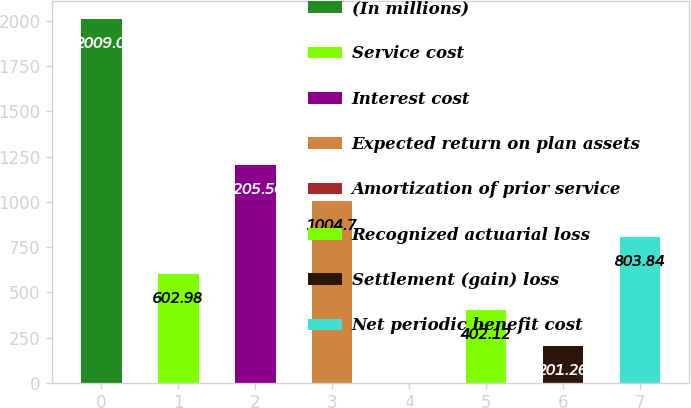Convert chart. <chart><loc_0><loc_0><loc_500><loc_500><bar_chart><fcel>(In millions)<fcel>Service cost<fcel>Interest cost<fcel>Expected return on plan assets<fcel>Amortization of prior service<fcel>Recognized actuarial loss<fcel>Settlement (gain) loss<fcel>Net periodic benefit cost<nl><fcel>2009<fcel>602.98<fcel>1205.56<fcel>1004.7<fcel>0.4<fcel>402.12<fcel>201.26<fcel>803.84<nl></chart> 